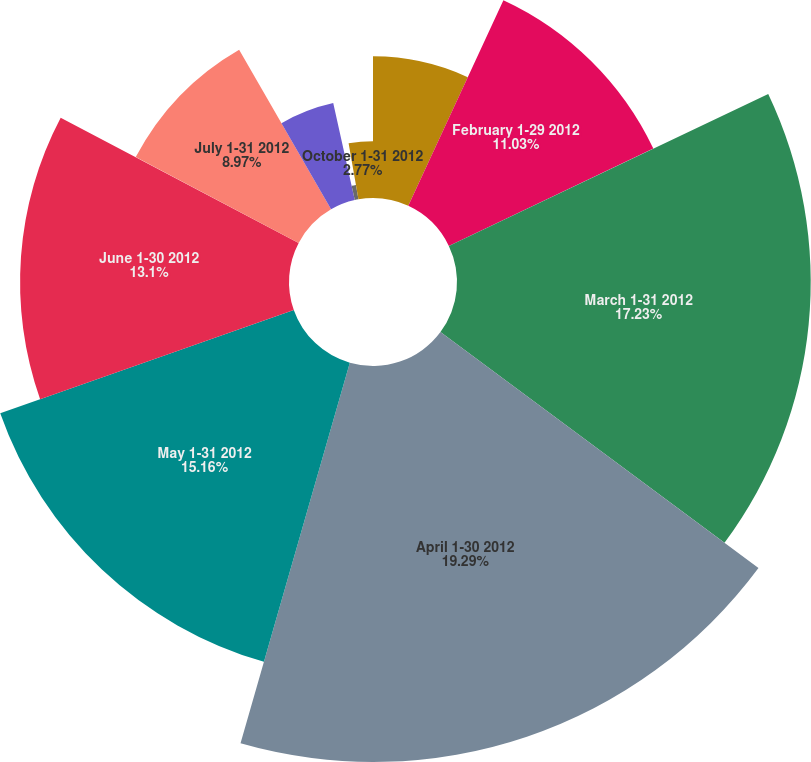Convert chart to OTSL. <chart><loc_0><loc_0><loc_500><loc_500><pie_chart><fcel>January 1-31 2012<fcel>February 1-29 2012<fcel>March 1-31 2012<fcel>April 1-30 2012<fcel>May 1-31 2012<fcel>June 1-30 2012<fcel>July 1-31 2012<fcel>August 1-31 2012<fcel>September 1-30 2012<fcel>October 1-31 2012<nl><fcel>6.9%<fcel>11.03%<fcel>17.23%<fcel>19.29%<fcel>15.16%<fcel>13.1%<fcel>8.97%<fcel>4.84%<fcel>0.71%<fcel>2.77%<nl></chart> 